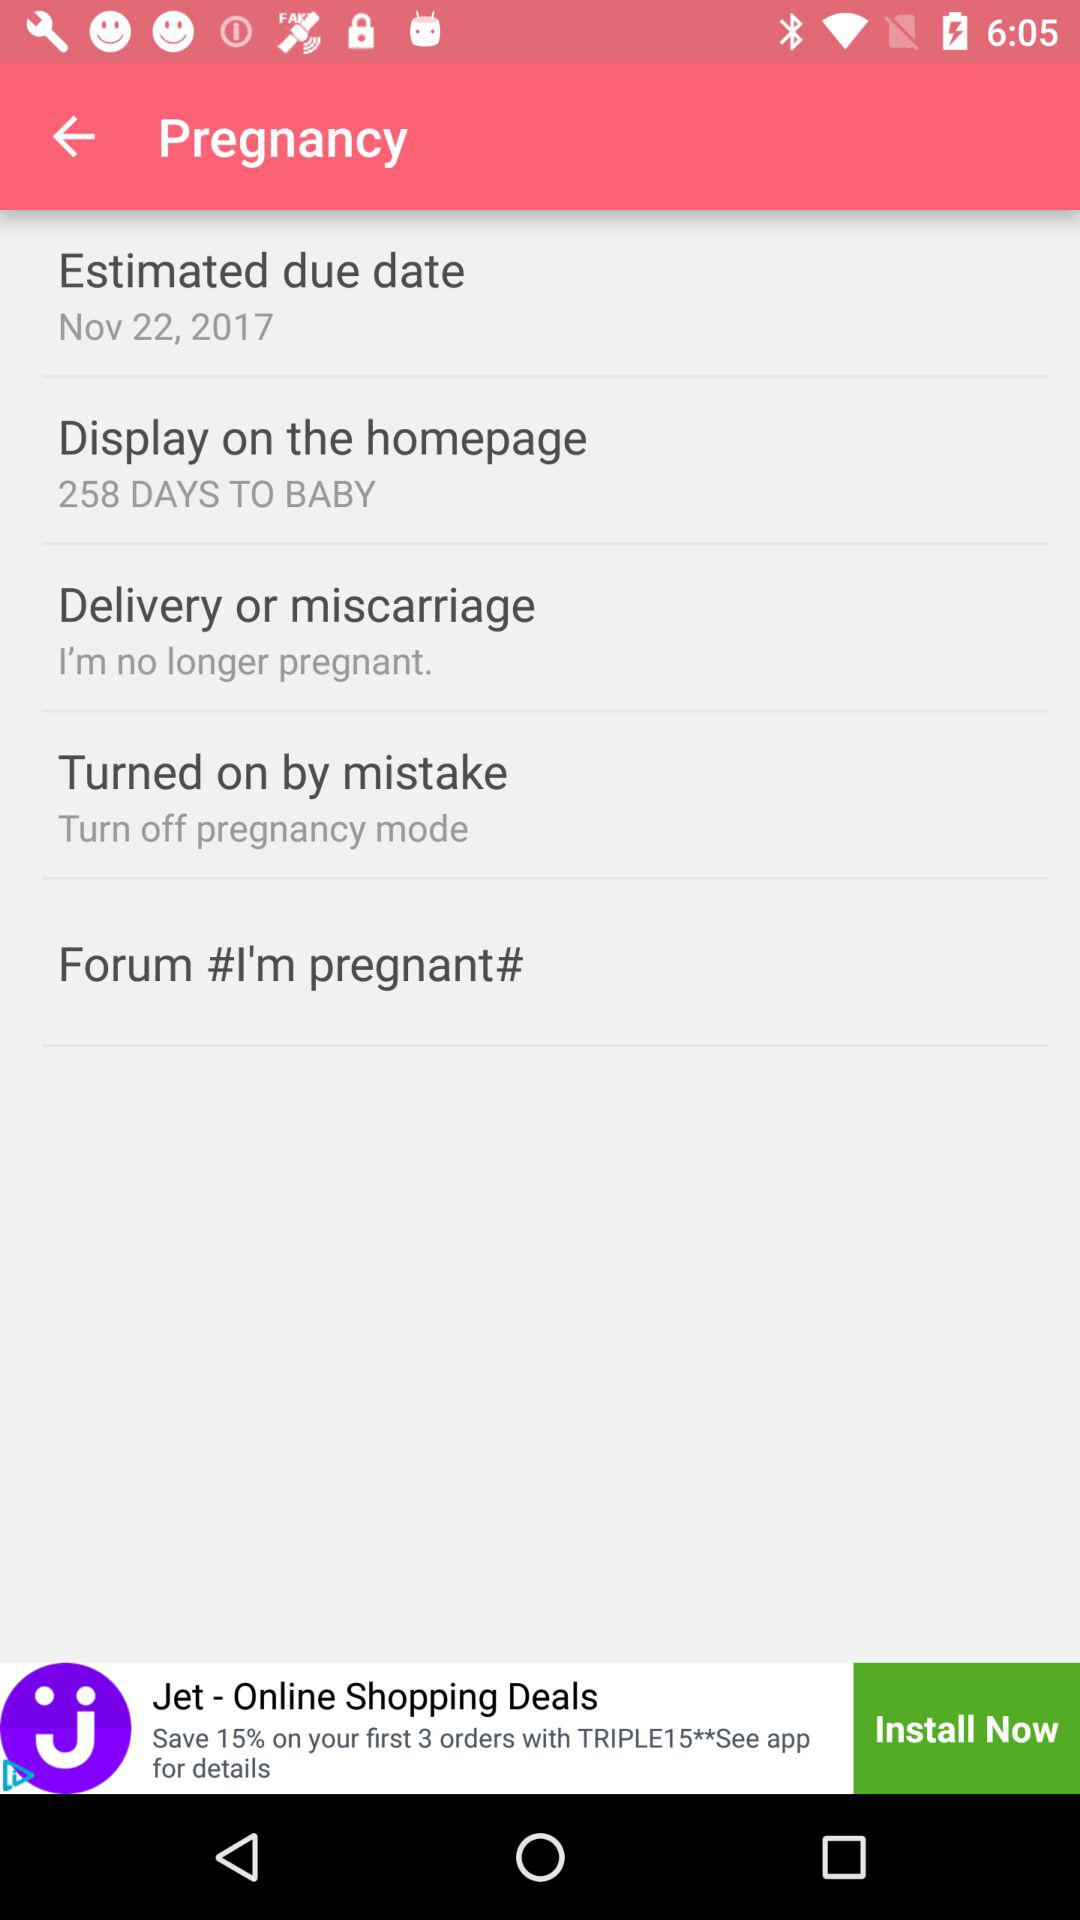What is the number of "DAYS TO BABY"? The number is 258. 